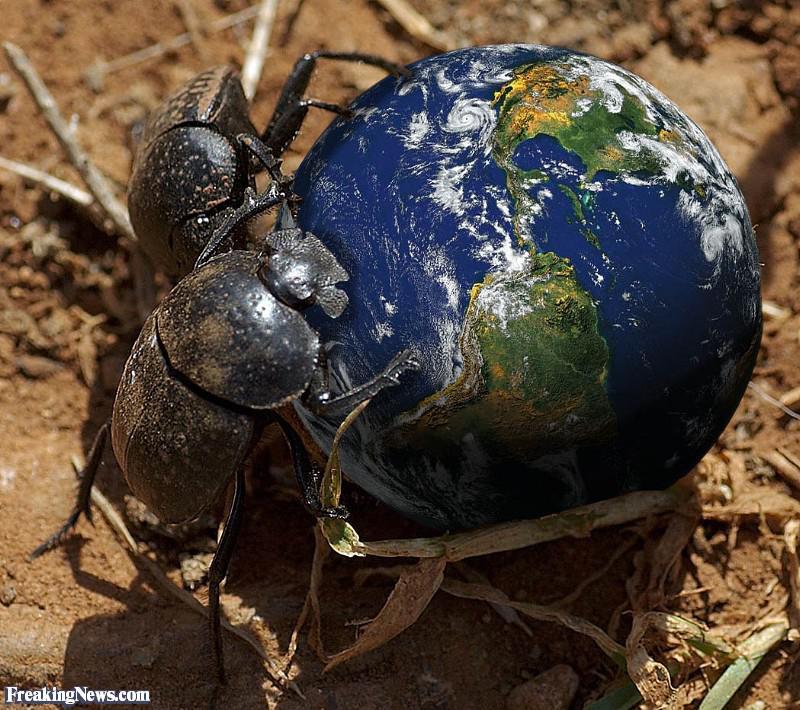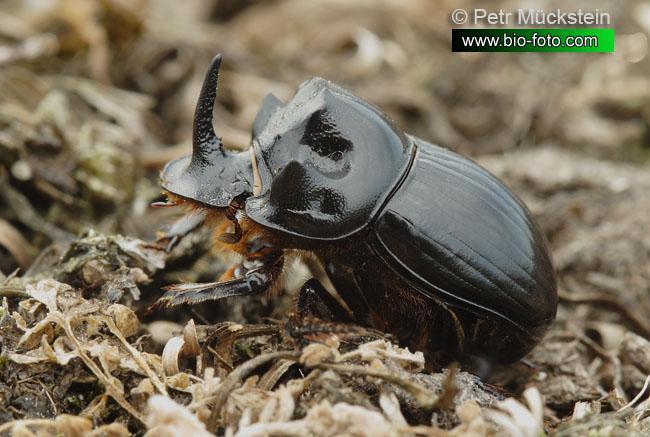The first image is the image on the left, the second image is the image on the right. Given the left and right images, does the statement "One image includes a beetle that is not in contact with a ball shape." hold true? Answer yes or no. Yes. The first image is the image on the left, the second image is the image on the right. Assess this claim about the two images: "Two beetles are on a blue ball.". Correct or not? Answer yes or no. Yes. 